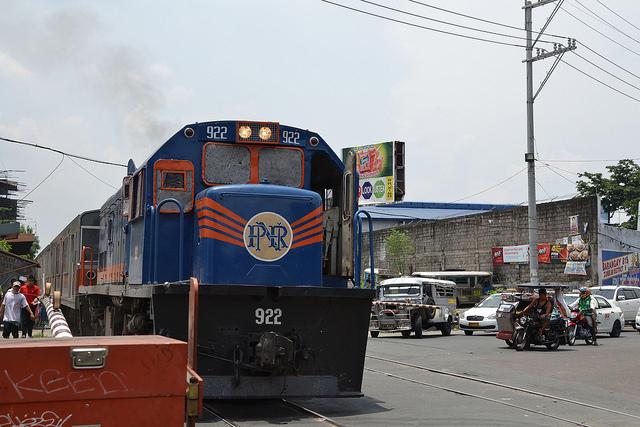Where is the scene?
Short answer required. Train station. What number is on the front of the train?
Give a very brief answer. 922. Are the lights on top of the train let up?
Write a very short answer. Yes. 